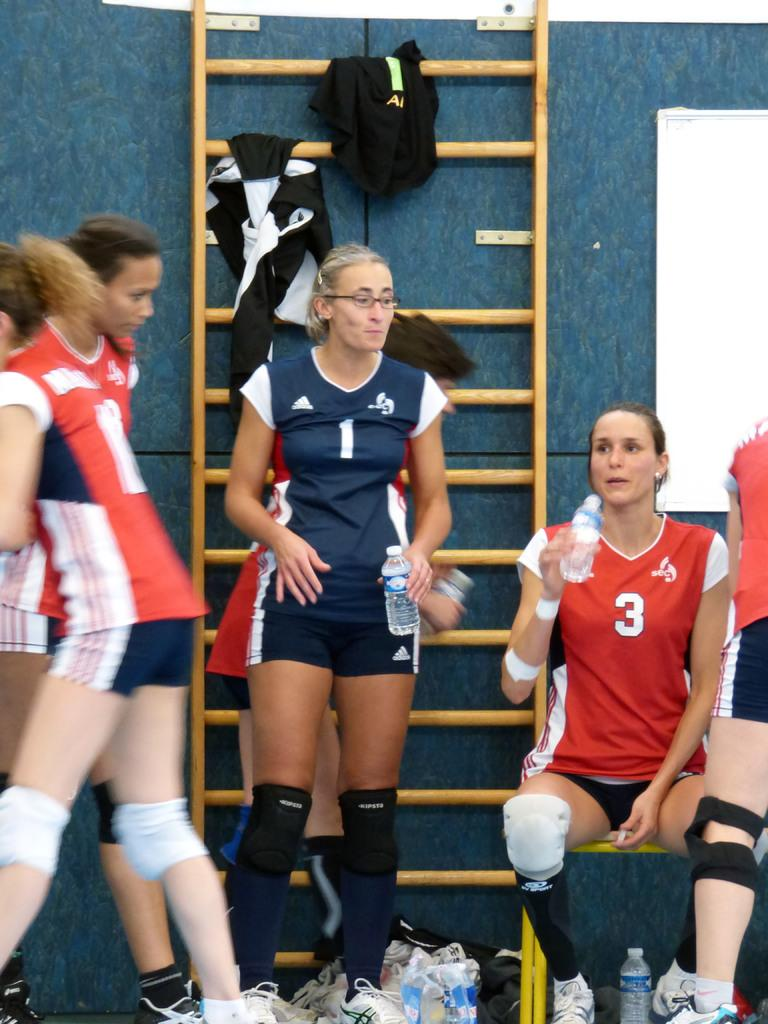<image>
Relay a brief, clear account of the picture shown. A group of volleyball players all wearing Addidas gear. 